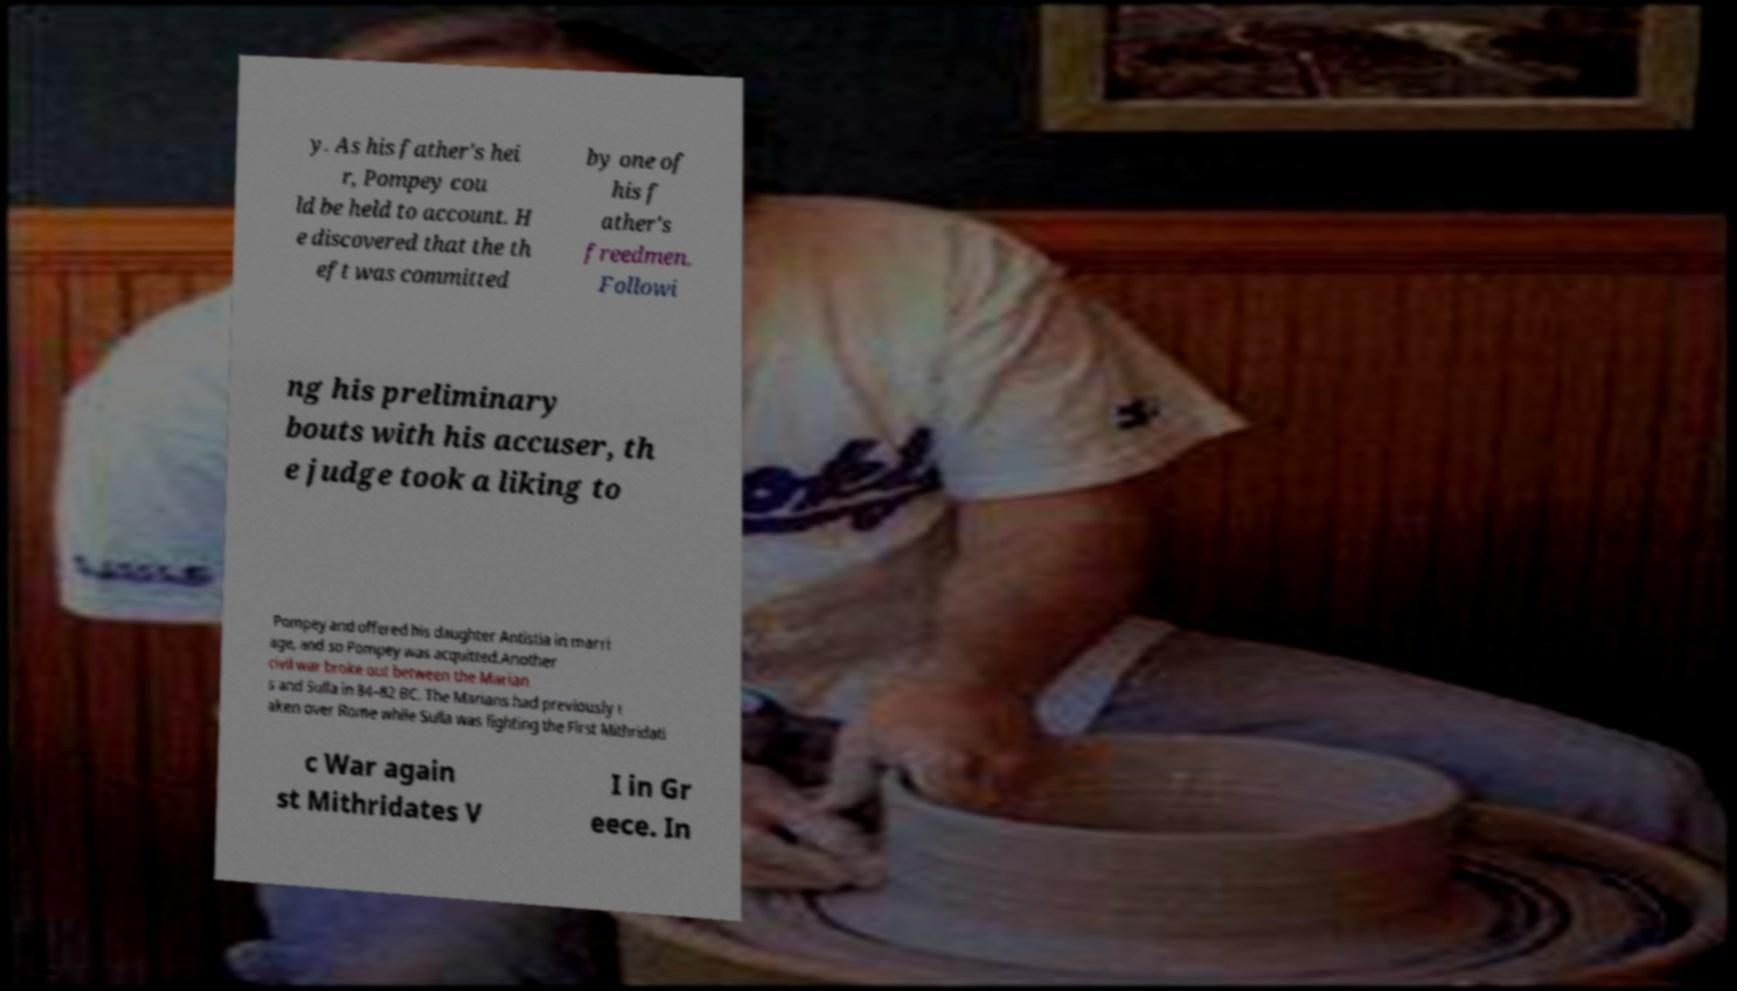For documentation purposes, I need the text within this image transcribed. Could you provide that? y. As his father's hei r, Pompey cou ld be held to account. H e discovered that the th eft was committed by one of his f ather's freedmen. Followi ng his preliminary bouts with his accuser, th e judge took a liking to Pompey and offered his daughter Antistia in marri age, and so Pompey was acquitted.Another civil war broke out between the Marian s and Sulla in 84–82 BC. The Marians had previously t aken over Rome while Sulla was fighting the First Mithridati c War again st Mithridates V I in Gr eece. In 